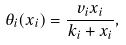Convert formula to latex. <formula><loc_0><loc_0><loc_500><loc_500>\theta _ { i } ( x _ { i } ) = \frac { v _ { i } x _ { i } } { k _ { i } + x _ { i } } ,</formula> 